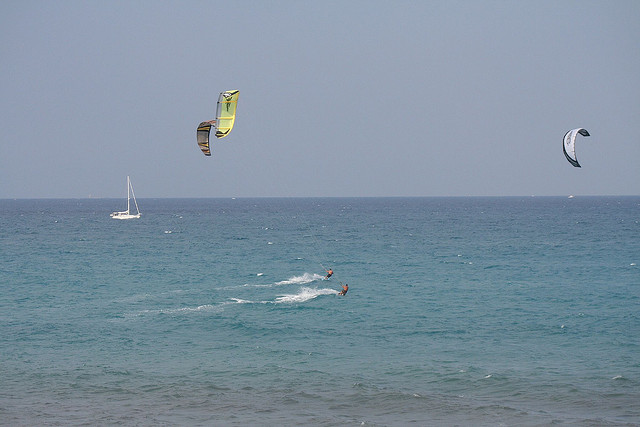Could you describe the environment where these water sports are taking place? Certainly, the image depicts an open water environment, likely a sea or ocean, given the visible horizon and the broad expanse of water. The clarity of the sky and calmness of the surface suggest moderate wind conditions, which are ideal for kitesurfing. Additionally, a sailboat is visible in the background, hinting that this area is used for various recreational boating activities. The context suggests a location that's popular for maritime leisure, possibly a coastal area frequented by water sports enthusiasts. 